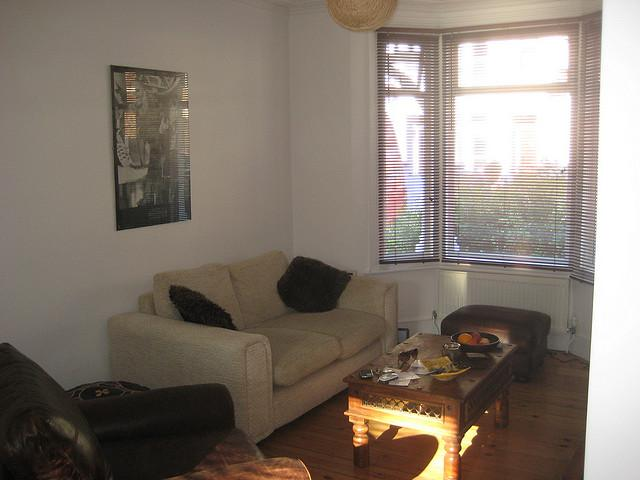What is on the wall?

Choices:
A) statue
B) cat
C) fly
D) picture picture 